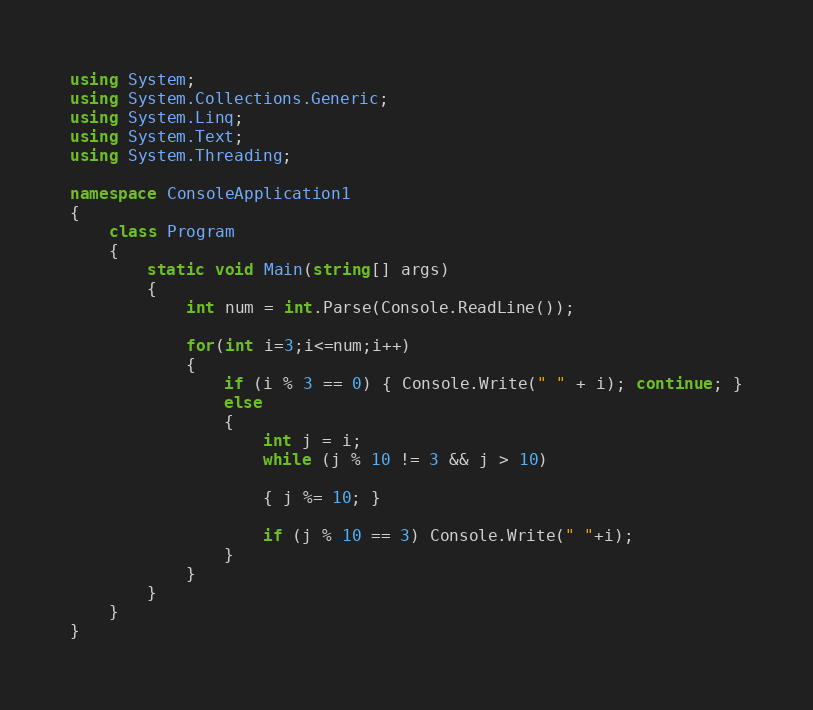<code> <loc_0><loc_0><loc_500><loc_500><_C#_>using System;
using System.Collections.Generic;
using System.Linq;
using System.Text;
using System.Threading;

namespace ConsoleApplication1
{
    class Program
    {
        static void Main(string[] args)
        {
            int num = int.Parse(Console.ReadLine());

            for(int i=3;i<=num;i++)
            {
                if (i % 3 == 0) { Console.Write(" " + i); continue; }
                else
                {
                    int j = i;
                    while (j % 10 != 3 && j > 10)

                    { j %= 10; }

                    if (j % 10 == 3) Console.Write(" "+i);
                }
            }
        }
    }
}</code> 